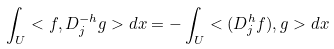<formula> <loc_0><loc_0><loc_500><loc_500>\int _ { U } < f , D ^ { - h } _ { j } g > d x = - \int _ { U } < ( D ^ { h } _ { j } f ) , g > d x</formula> 